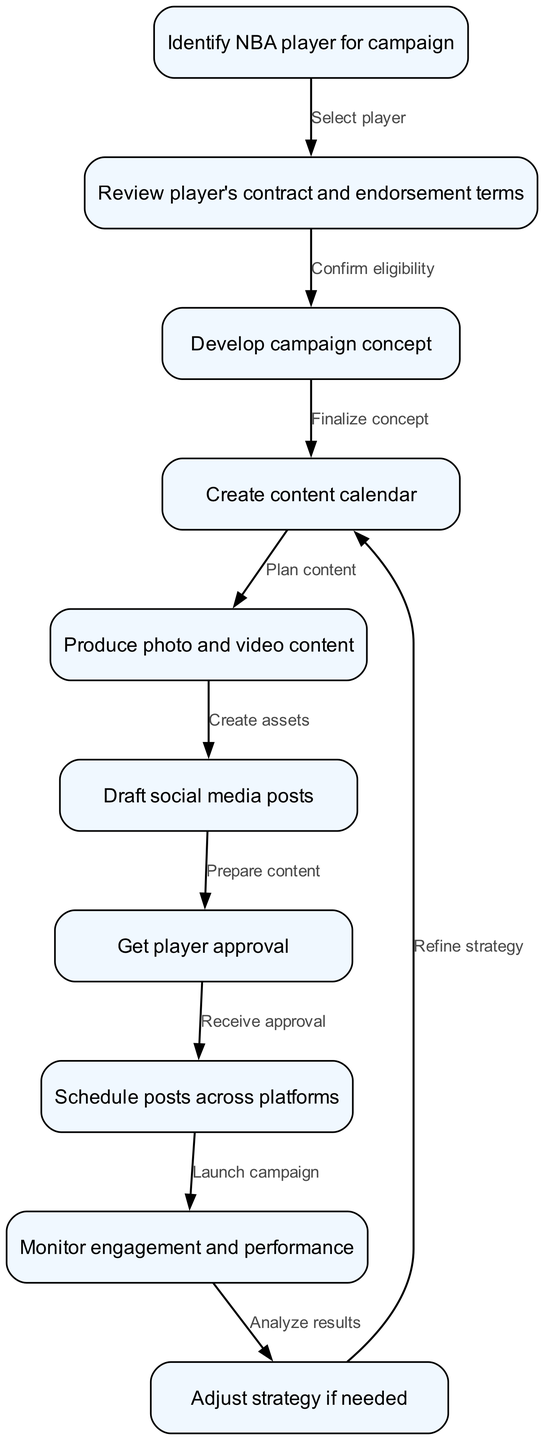What is the first step in the workflow? The first step in the workflow is to identify an NBA player for the campaign. This is indicated as the starting node in the diagram.
Answer: Identify NBA player for campaign How many nodes are in the diagram? By counting all the unique process steps represented in the diagram, we total ten nodes. Each node corresponds to a specific step in the workflow.
Answer: 10 What is the last step before launching the campaign? The last step before launching the campaign is to receive player approval. This step is the direct predecessor to the launch, as indicated by the arrow connecting these nodes.
Answer: Get player approval Which node follows the 'Monitor engagement and performance' step? The node that follows 'Monitor engagement and performance' is 'Adjust strategy if needed'. This is identified by the directional flow from the performance monitoring step to the strategy adjustment step.
Answer: Adjust strategy if needed What are the two nodes connected by the edge labeled 'Plan content'? The edge labeled 'Plan content' connects the nodes 'Create content calendar' and 'Produce photo and video content'. This indicates that after a content calendar is created, the content production phase begins.
Answer: Create content calendar, Produce photo and video content What step confirms eligibility before developing the campaign concept? The step that confirms eligibility before developing the campaign concept is 'Review player's contract and endorsement terms'. This step is crucial for ensuring that the player can participate in the campaign.
Answer: Review player's contract and endorsement terms How many edges are in the diagram? The diagram contains nine edges, which represent the connections between the nodes in the flow of the workflow. Each edge corresponds to a directional relationship between two tasks.
Answer: 9 Which two nodes are directly connected to the 'Produce photo and video content' node? The 'Produce photo and video content' node is directly connected to 'Create content calendar' and 'Draft social media posts'. This shows that content production follows the planning and precedes the drafting of social media posts.
Answer: Create content calendar, Draft social media posts 